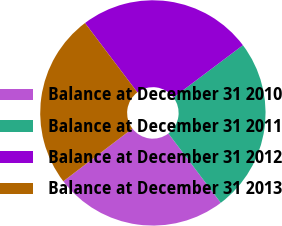<chart> <loc_0><loc_0><loc_500><loc_500><pie_chart><fcel>Balance at December 31 2010<fcel>Balance at December 31 2011<fcel>Balance at December 31 2012<fcel>Balance at December 31 2013<nl><fcel>24.92%<fcel>24.97%<fcel>25.03%<fcel>25.08%<nl></chart> 